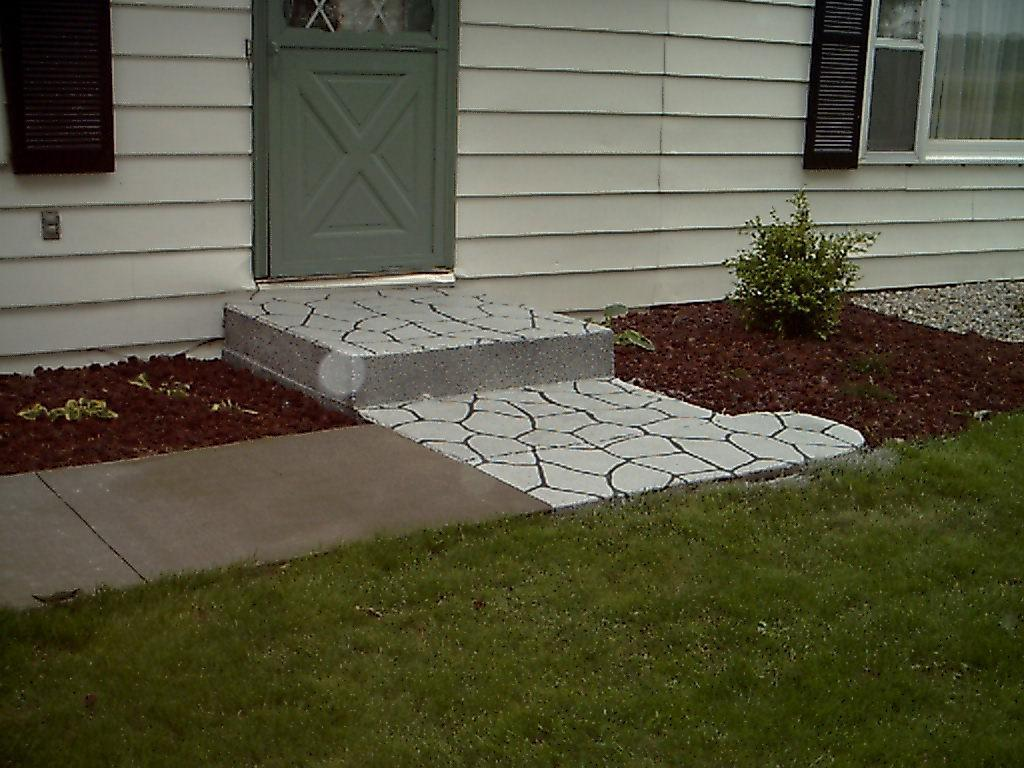What type of building is visible in the image? There is a house in the image. What are some features of the house? There is a door and a window in the image. What is located near the house? There is a plant and grass in the front of the image. How does the beggar say good-bye to the house in the image? There is no beggar present in the image, and therefore no such interaction can be observed. 